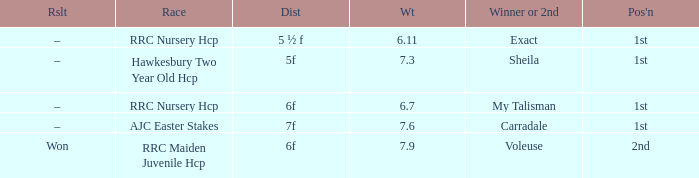What is the largest weight wth a Result of –, and a Distance of 7f? 7.6. 